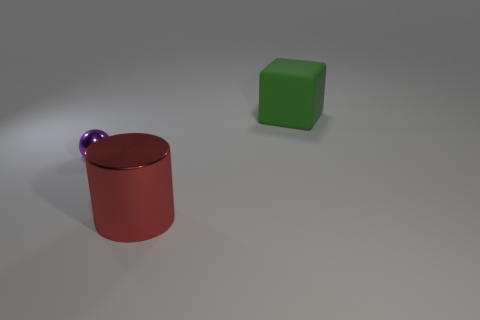Add 2 green matte blocks. How many objects exist? 5 Subtract all cylinders. How many objects are left? 2 Subtract 0 blue cylinders. How many objects are left? 3 Subtract all big red cylinders. Subtract all small purple metallic balls. How many objects are left? 1 Add 1 small purple balls. How many small purple balls are left? 2 Add 2 red things. How many red things exist? 3 